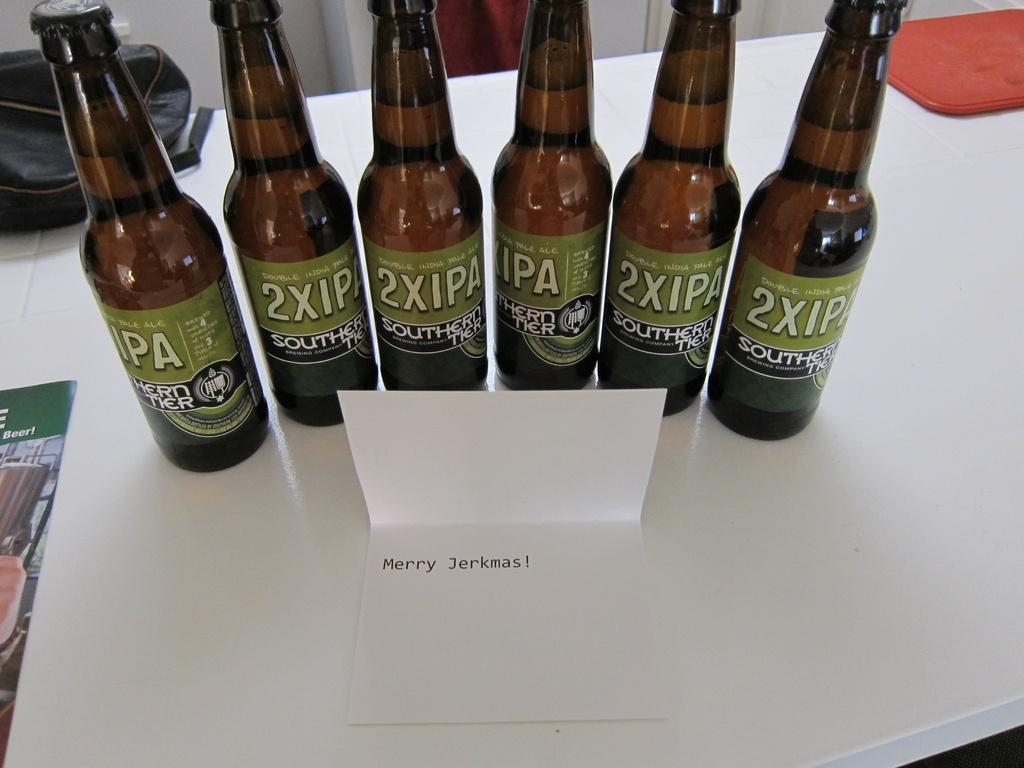<image>
Describe the image concisely. 6 dark color bottles of 2XIPA Sothern Tier Double India Pale ale 